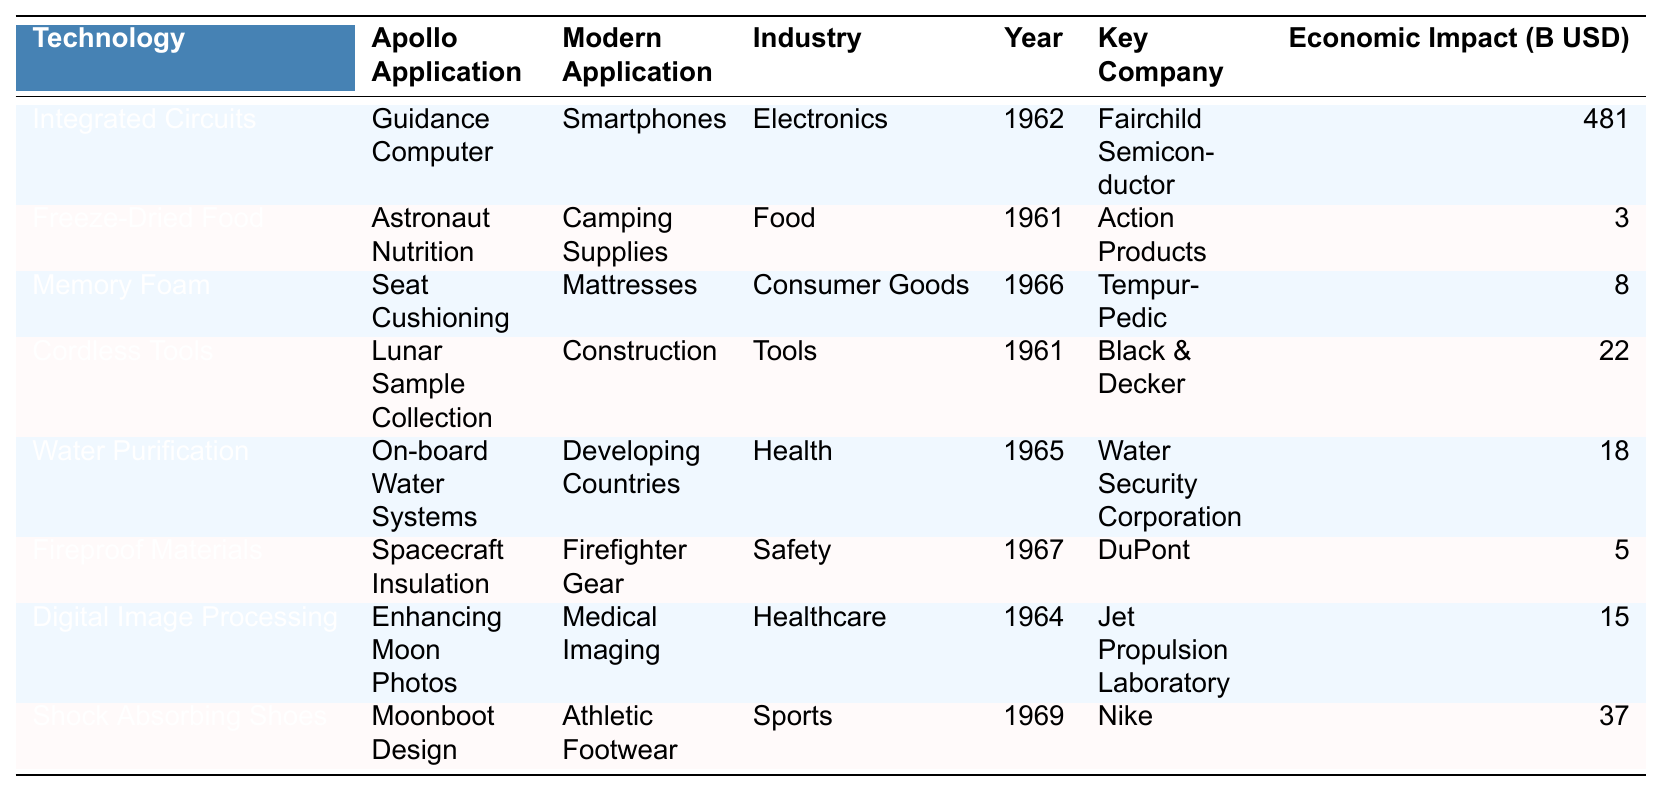What technological advancement from the Apollo program is associated with smartphones? The table shows that Integrated Circuits were used in the Apollo Guidance Computer and are associated with modern smartphones.
Answer: Integrated Circuits Which technology has the highest economic impact in billions of USD? By examining the Economic Impact column, Integrated Circuits have an impact of 481 billion USD, which is the highest among all technologies listed.
Answer: 481 billion USD What year was freeze-dried food first introduced? The Year Introduced column indicates that freeze-dried food was introduced in 1961.
Answer: 1961 How many technologies have applications in the healthcare industry? Referring to the Industry column, Digital Image Processing and Water Purification are the two technologies listed under healthcare, totaling to two.
Answer: 2 What is the economic impact of memory foam technologies? The table lists the economic impact of Memory Foam as 8 billion USD, which is a direct retrieval from the Economic Impact column.
Answer: 8 billion USD Which technology was introduced first, freeze-dried food or water purification? Freeze-Dried Food was introduced in 1961, while Water Purification was introduced in 1965. Since 1961 is earlier than 1965, freeze-dried food was introduced first.
Answer: Freeze-Dried Food Is it true that all listed technologies were introduced in the 1960s? If we check the Year Introduced column closely, we see that freeze-dried food and cordless tools were introduced in 1961, which is in the 1960s, while Integrated Circuits were introduced in 1962 and Water Purification in 1965, both also in the 1960s. However, it should be noted that Shock Absorbing Shoes were introduced in 1969, which still falls within the 1960s. Therefore, the claim holds true.
Answer: Yes What is the total economic impact of technologies in the food industry? The Economic Impact for Freeze-Dried Food is 3 billion USD and there are no other food technologies on the list according to the Industry column. Therefore, the total is 3 billion USD.
Answer: 3 billion USD How much more economic impact does shock absorbing shoes have compared to fireproof materials? Shock Absorbing Shoes have an economic impact of 37 billion USD and Fireproof Materials have an impact of 5 billion USD. Subtracting these gives 37 - 5 = 32 billion USD.
Answer: 32 billion USD Which key company is associated with the development of water purification technology? From the table, it is clear that Water Security Corporation is the key company associated with the development of water purification technology.
Answer: Water Security Corporation 